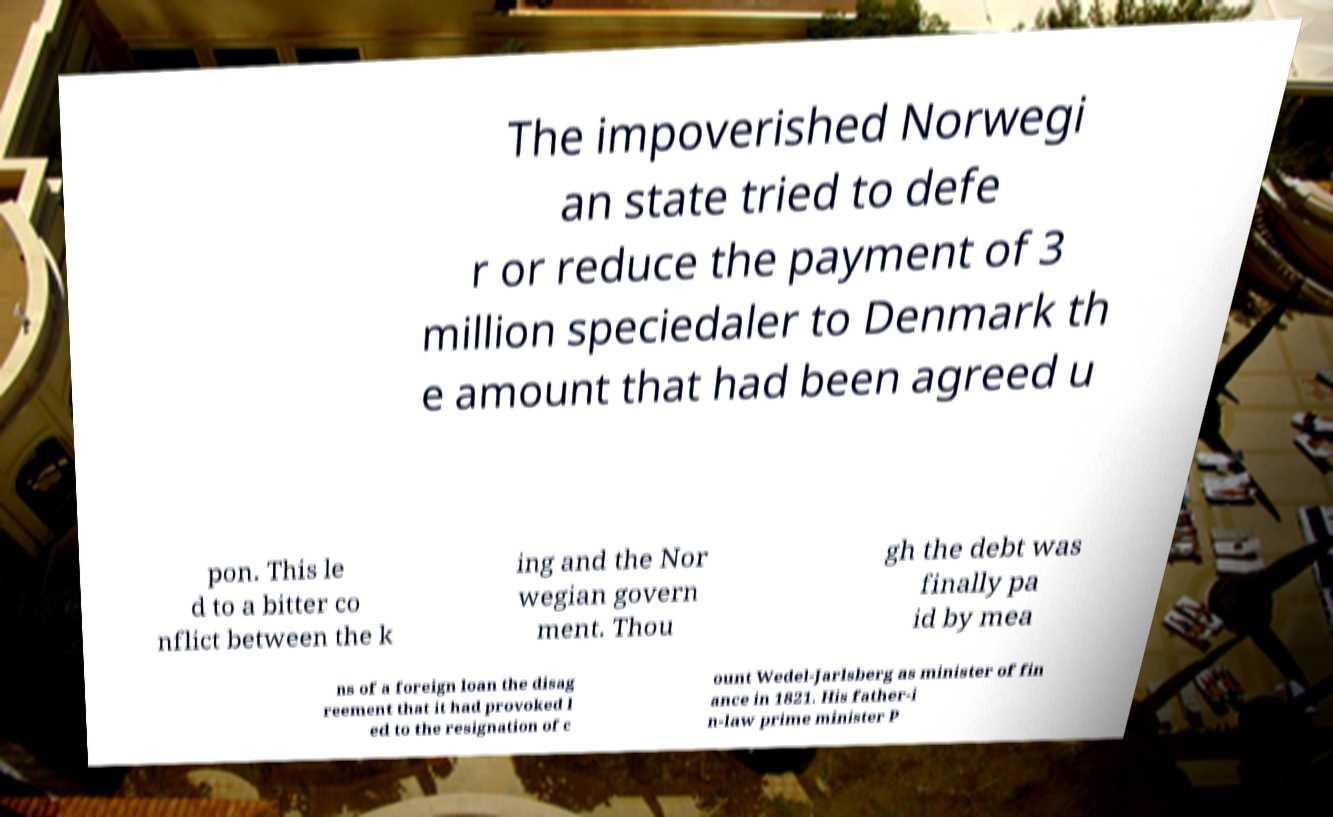I need the written content from this picture converted into text. Can you do that? The impoverished Norwegi an state tried to defe r or reduce the payment of 3 million speciedaler to Denmark th e amount that had been agreed u pon. This le d to a bitter co nflict between the k ing and the Nor wegian govern ment. Thou gh the debt was finally pa id by mea ns of a foreign loan the disag reement that it had provoked l ed to the resignation of c ount Wedel-Jarlsberg as minister of fin ance in 1821. His father-i n-law prime minister P 